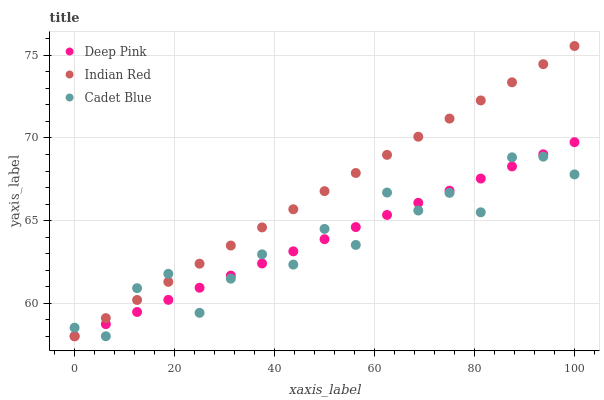Does Cadet Blue have the minimum area under the curve?
Answer yes or no. Yes. Does Indian Red have the maximum area under the curve?
Answer yes or no. Yes. Does Deep Pink have the minimum area under the curve?
Answer yes or no. No. Does Deep Pink have the maximum area under the curve?
Answer yes or no. No. Is Deep Pink the smoothest?
Answer yes or no. Yes. Is Cadet Blue the roughest?
Answer yes or no. Yes. Is Indian Red the smoothest?
Answer yes or no. No. Is Indian Red the roughest?
Answer yes or no. No. Does Cadet Blue have the lowest value?
Answer yes or no. Yes. Does Indian Red have the highest value?
Answer yes or no. Yes. Does Deep Pink have the highest value?
Answer yes or no. No. Does Deep Pink intersect Indian Red?
Answer yes or no. Yes. Is Deep Pink less than Indian Red?
Answer yes or no. No. Is Deep Pink greater than Indian Red?
Answer yes or no. No. 